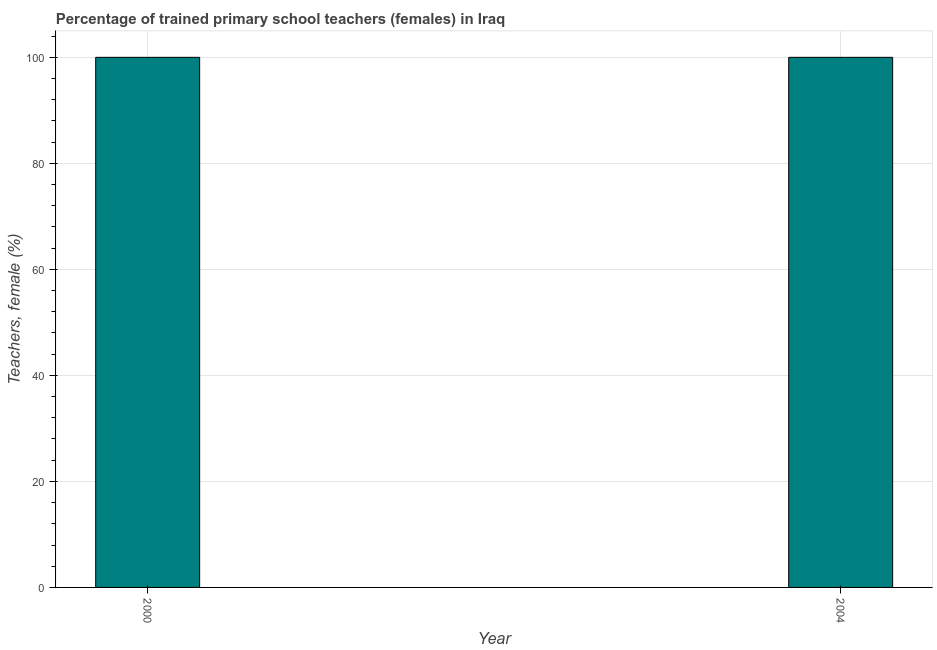Does the graph contain any zero values?
Provide a short and direct response. No. Does the graph contain grids?
Make the answer very short. Yes. What is the title of the graph?
Give a very brief answer. Percentage of trained primary school teachers (females) in Iraq. What is the label or title of the Y-axis?
Provide a short and direct response. Teachers, female (%). What is the percentage of trained female teachers in 2004?
Make the answer very short. 100. What is the sum of the percentage of trained female teachers?
Provide a short and direct response. 200. What is the median percentage of trained female teachers?
Provide a short and direct response. 100. In how many years, is the percentage of trained female teachers greater than 76 %?
Your answer should be very brief. 2. What is the ratio of the percentage of trained female teachers in 2000 to that in 2004?
Offer a very short reply. 1. Are the values on the major ticks of Y-axis written in scientific E-notation?
Give a very brief answer. No. What is the Teachers, female (%) of 2000?
Offer a terse response. 100. What is the difference between the Teachers, female (%) in 2000 and 2004?
Ensure brevity in your answer.  0. What is the ratio of the Teachers, female (%) in 2000 to that in 2004?
Give a very brief answer. 1. 